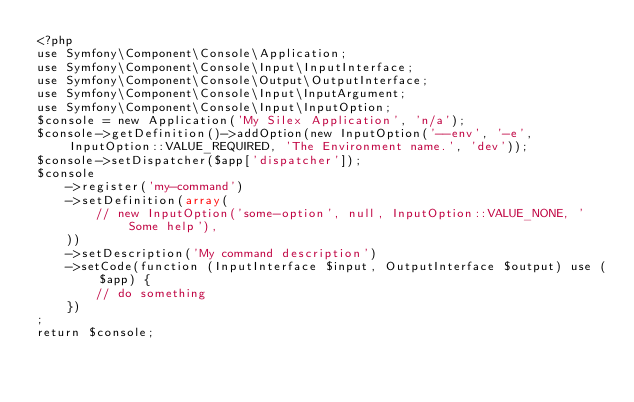<code> <loc_0><loc_0><loc_500><loc_500><_PHP_><?php
use Symfony\Component\Console\Application;
use Symfony\Component\Console\Input\InputInterface;
use Symfony\Component\Console\Output\OutputInterface;
use Symfony\Component\Console\Input\InputArgument;
use Symfony\Component\Console\Input\InputOption;
$console = new Application('My Silex Application', 'n/a');
$console->getDefinition()->addOption(new InputOption('--env', '-e', InputOption::VALUE_REQUIRED, 'The Environment name.', 'dev'));
$console->setDispatcher($app['dispatcher']);
$console
    ->register('my-command')
    ->setDefinition(array(
        // new InputOption('some-option', null, InputOption::VALUE_NONE, 'Some help'),
    ))
    ->setDescription('My command description')
    ->setCode(function (InputInterface $input, OutputInterface $output) use ($app) {
        // do something
    })
;
return $console;
</code> 